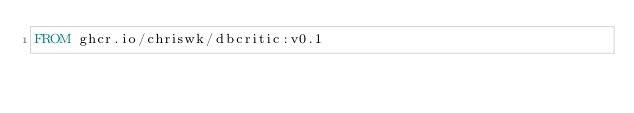<code> <loc_0><loc_0><loc_500><loc_500><_Dockerfile_>FROM ghcr.io/chriswk/dbcritic:v0.1</code> 